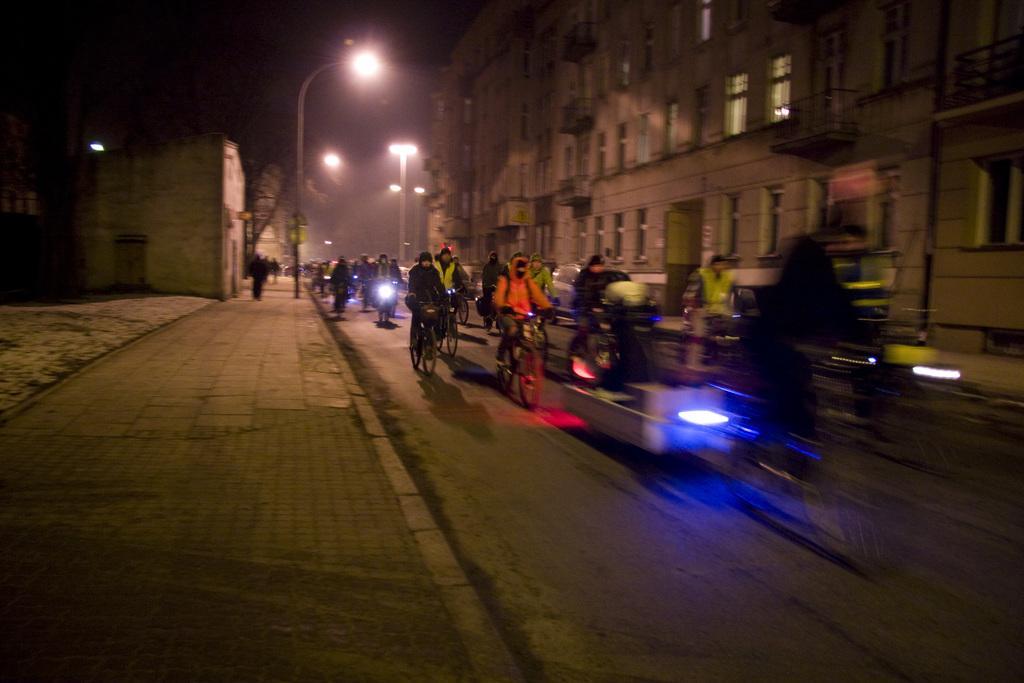Can you describe this image briefly? In this picture there are people riding vehicles on the road and we can see light poles and buildings. In the background of the image it is dark and we can see people and tree. 